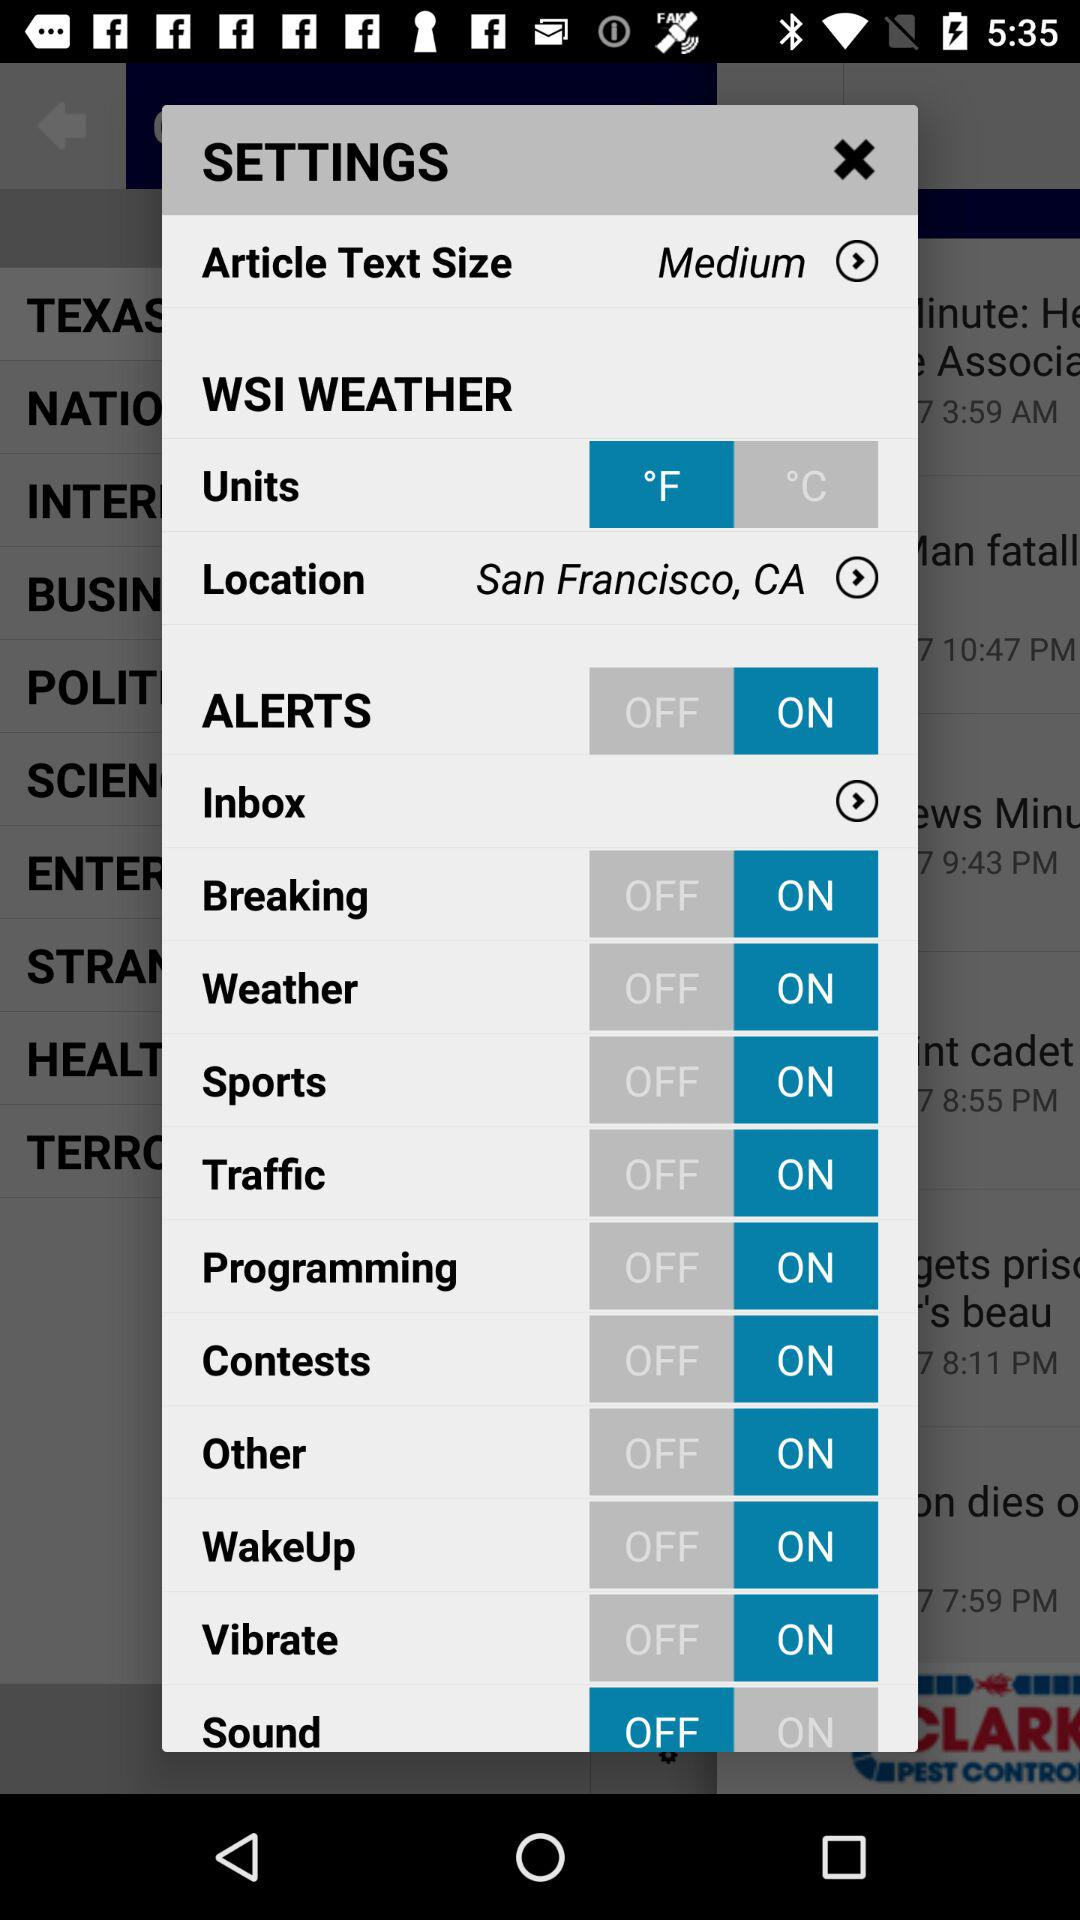What is the status of the "Breaking"? The status of the "Breaking" is "on". 